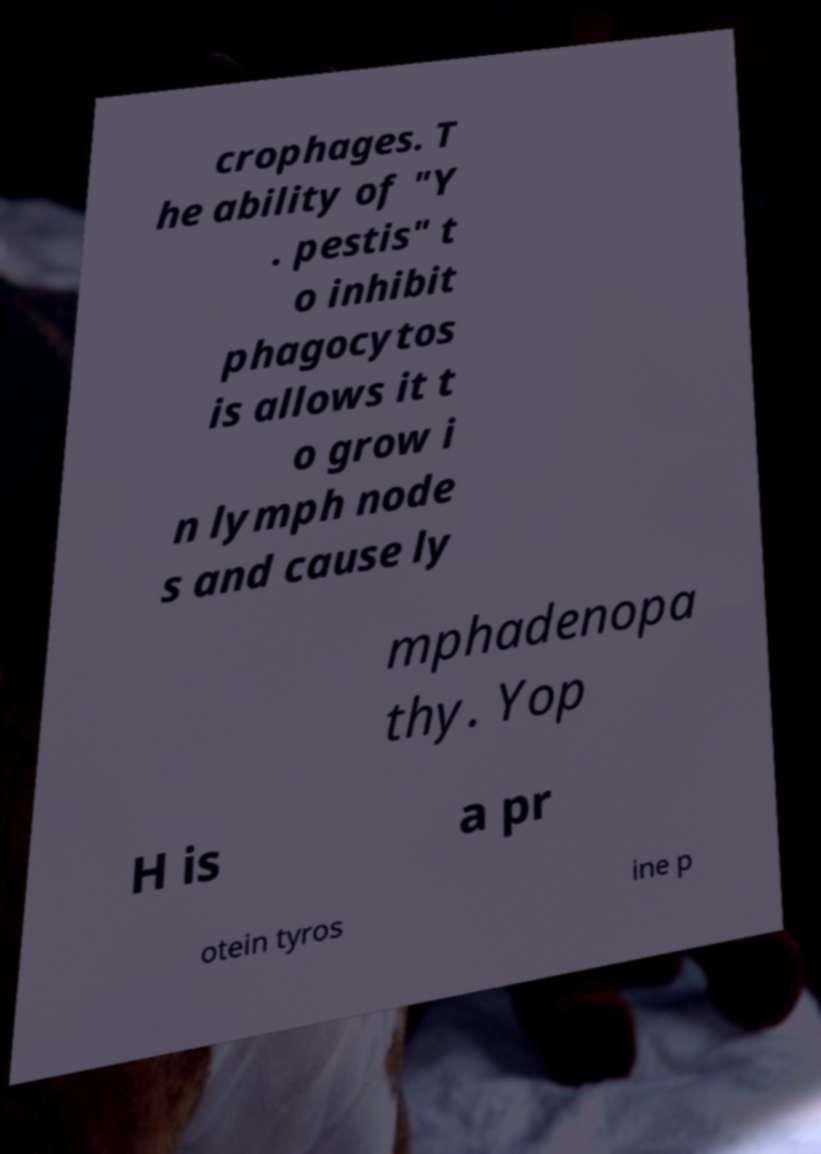Could you assist in decoding the text presented in this image and type it out clearly? crophages. T he ability of "Y . pestis" t o inhibit phagocytos is allows it t o grow i n lymph node s and cause ly mphadenopa thy. Yop H is a pr otein tyros ine p 